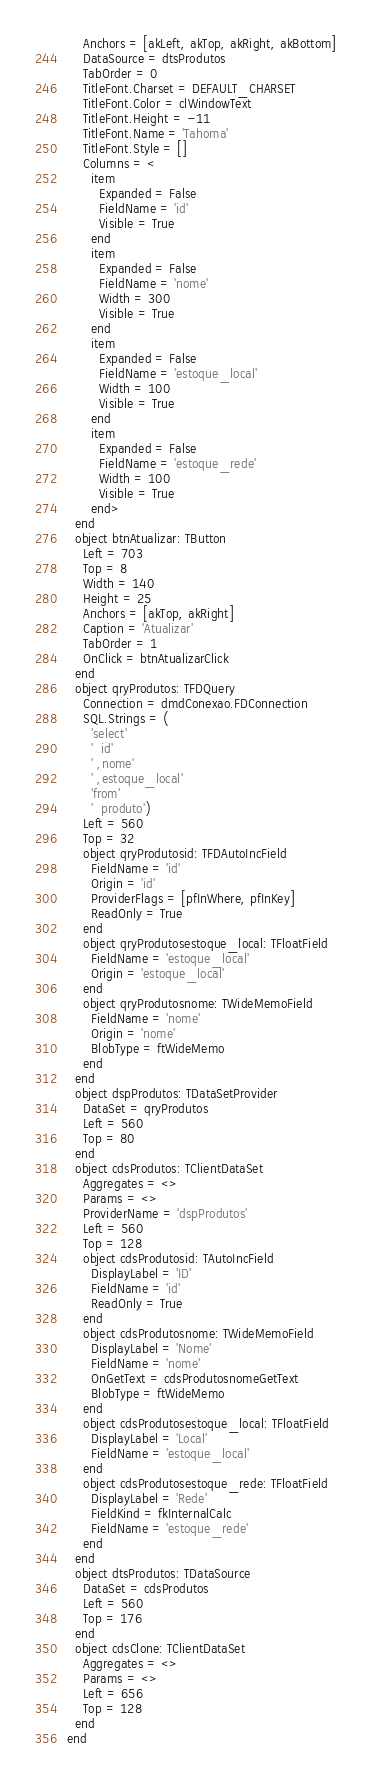<code> <loc_0><loc_0><loc_500><loc_500><_Pascal_>    Anchors = [akLeft, akTop, akRight, akBottom]
    DataSource = dtsProdutos
    TabOrder = 0
    TitleFont.Charset = DEFAULT_CHARSET
    TitleFont.Color = clWindowText
    TitleFont.Height = -11
    TitleFont.Name = 'Tahoma'
    TitleFont.Style = []
    Columns = <
      item
        Expanded = False
        FieldName = 'id'
        Visible = True
      end
      item
        Expanded = False
        FieldName = 'nome'
        Width = 300
        Visible = True
      end
      item
        Expanded = False
        FieldName = 'estoque_local'
        Width = 100
        Visible = True
      end
      item
        Expanded = False
        FieldName = 'estoque_rede'
        Width = 100
        Visible = True
      end>
  end
  object btnAtualizar: TButton
    Left = 703
    Top = 8
    Width = 140
    Height = 25
    Anchors = [akTop, akRight]
    Caption = 'Atualizar'
    TabOrder = 1
    OnClick = btnAtualizarClick
  end
  object qryProdutos: TFDQuery
    Connection = dmdConexao.FDConnection
    SQL.Strings = (
      'select'
      '  id'
      ' ,nome'
      ' ,estoque_local'
      'from'
      '  produto')
    Left = 560
    Top = 32
    object qryProdutosid: TFDAutoIncField
      FieldName = 'id'
      Origin = 'id'
      ProviderFlags = [pfInWhere, pfInKey]
      ReadOnly = True
    end
    object qryProdutosestoque_local: TFloatField
      FieldName = 'estoque_local'
      Origin = 'estoque_local'
    end
    object qryProdutosnome: TWideMemoField
      FieldName = 'nome'
      Origin = 'nome'
      BlobType = ftWideMemo
    end
  end
  object dspProdutos: TDataSetProvider
    DataSet = qryProdutos
    Left = 560
    Top = 80
  end
  object cdsProdutos: TClientDataSet
    Aggregates = <>
    Params = <>
    ProviderName = 'dspProdutos'
    Left = 560
    Top = 128
    object cdsProdutosid: TAutoIncField
      DisplayLabel = 'ID'
      FieldName = 'id'
      ReadOnly = True
    end
    object cdsProdutosnome: TWideMemoField
      DisplayLabel = 'Nome'
      FieldName = 'nome'
      OnGetText = cdsProdutosnomeGetText
      BlobType = ftWideMemo
    end
    object cdsProdutosestoque_local: TFloatField
      DisplayLabel = 'Local'
      FieldName = 'estoque_local'
    end
    object cdsProdutosestoque_rede: TFloatField
      DisplayLabel = 'Rede'
      FieldKind = fkInternalCalc
      FieldName = 'estoque_rede'
    end
  end
  object dtsProdutos: TDataSource
    DataSet = cdsProdutos
    Left = 560
    Top = 176
  end
  object cdsClone: TClientDataSet
    Aggregates = <>
    Params = <>
    Left = 656
    Top = 128
  end
end
</code> 